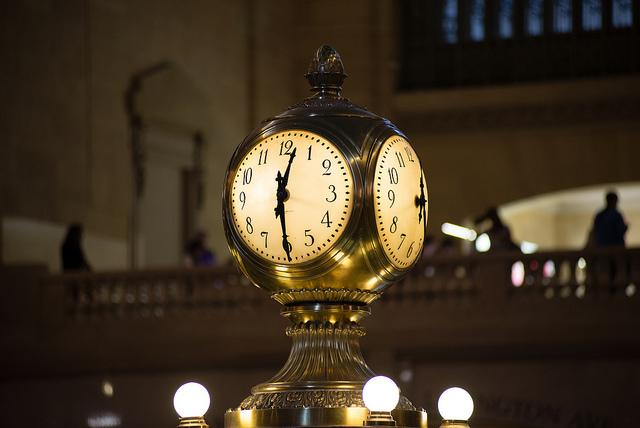If the clock is showing times in the PM how many hours ago did the New York Stock Exchange open?

Choices:
A) one
B) three
C) four
D) six three 